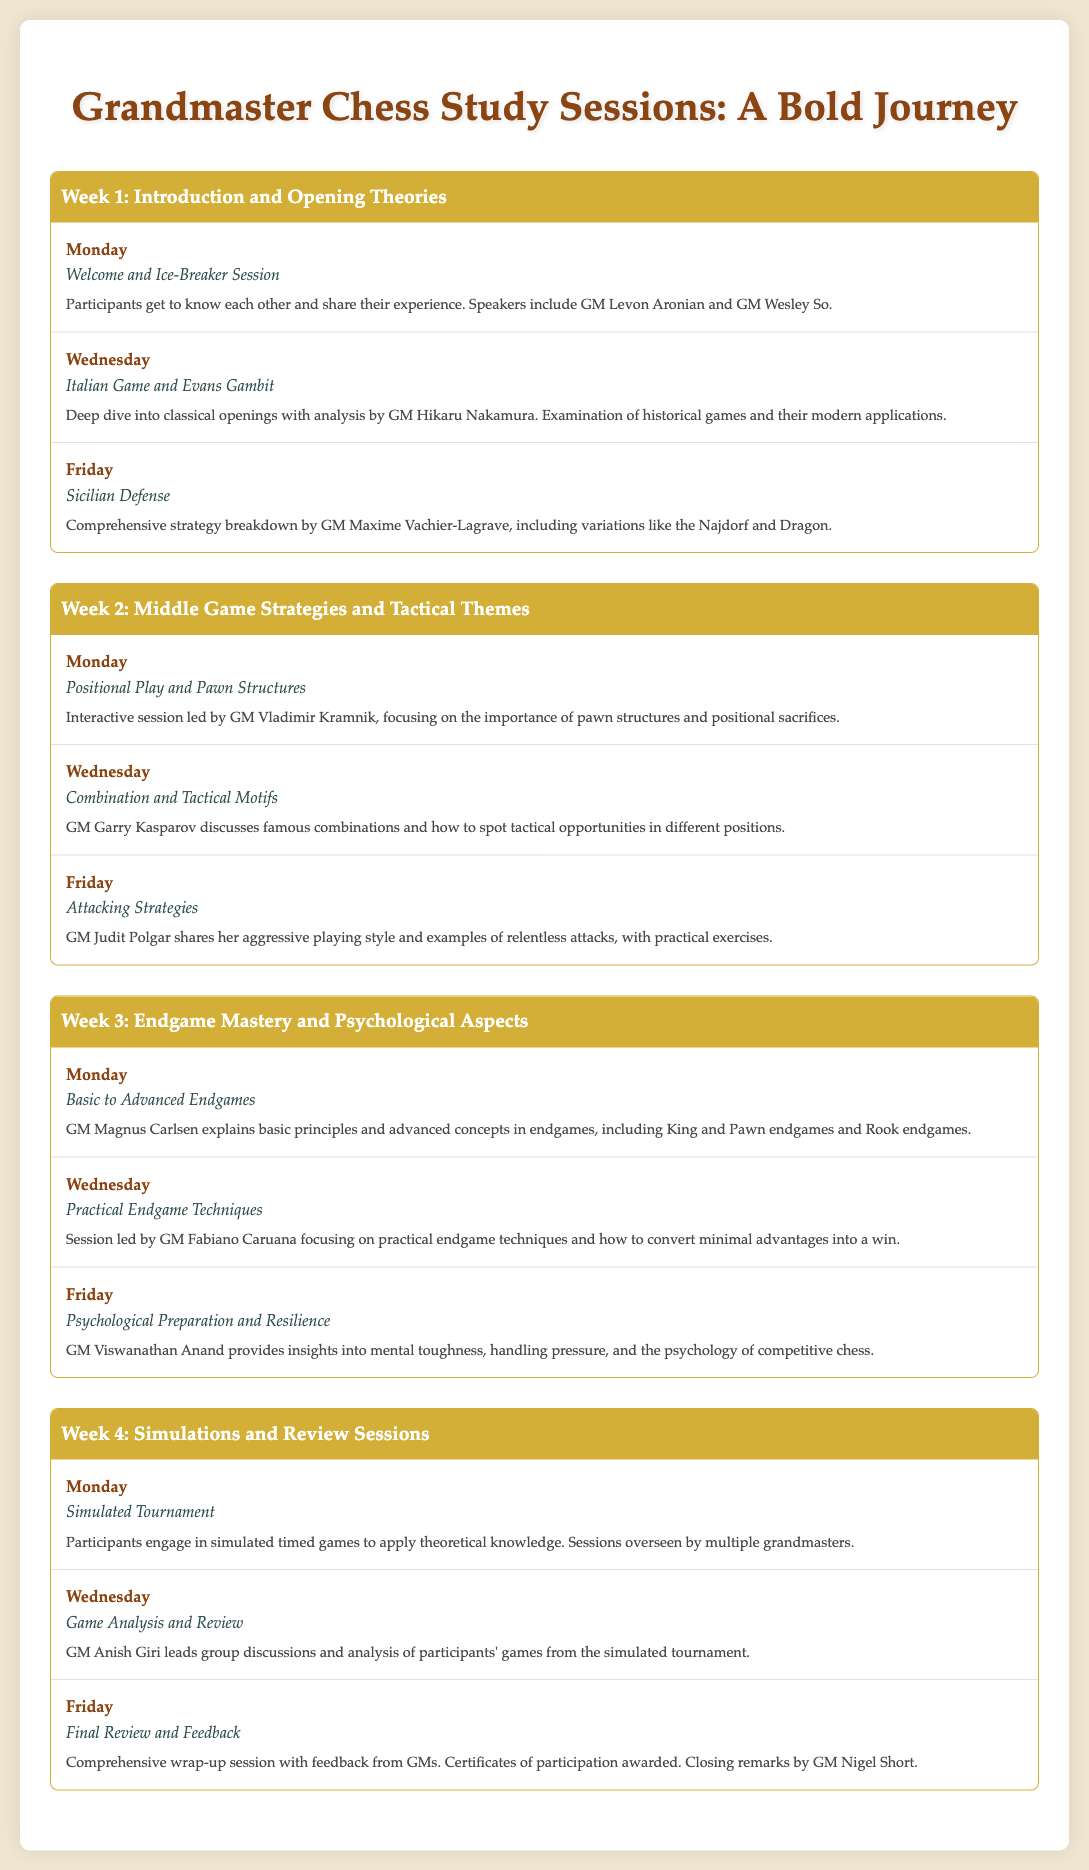what is the title of the document? The title is found at the top of the document and gives a clear idea of the content, which is "Grandmaster Chess Study Sessions: A Bold Journey."
Answer: Grandmaster Chess Study Sessions: A Bold Journey who leads the session on Sicilian Defense? The document explicitly states that GM Maxime Vachier-Lagrave provides the comprehensive strategy breakdown for the Sicilian Defense.
Answer: GM Maxime Vachier-Lagrave how many sessions are held in Week 2? Each week has three sessions listed, and since Week 2 is no exception, it has three specific sessions detailed.
Answer: 3 which grandmaster discusses psychological preparation? The document indicates that GM Viswanathan Anand talks about psychological preparation and resilience during the endgame week.
Answer: GM Viswanathan Anand what is the main focus of Week 1? The first week’s title is a strong reflection of its content, which revolves around opening theories in chess.
Answer: Introduction and Opening Theories name one tactical theme discussed in Week 2. The document mentions "Combination and Tactical Motifs" as one of the key activities in Week 2 led by GM Garry Kasparov.
Answer: Combination and Tactical Motifs who oversees the final review session? The document specifies that the final review and feedback session includes closing remarks by GM Nigel Short.
Answer: GM Nigel Short what type of event occurs on the last Monday? The last Monday's activity is a simulated event that participants engage in to apply what they've learned.
Answer: Simulated Tournament which grandmaster is known for their aggressive playing style? The document highlights GM Judit Polgar's aggressive style during the session on attacking strategies.
Answer: GM Judit Polgar 